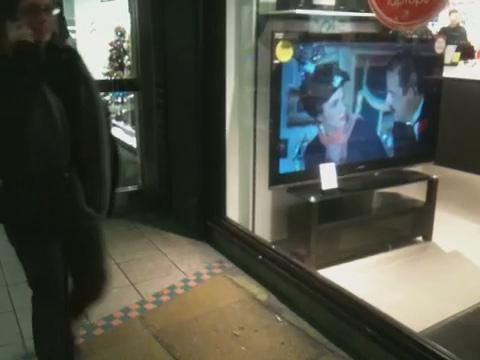Question: why is it blurry?
Choices:
A. Camera out of focus.
B. There is a smudge.
C. It is seen through a window.
D. The camera was shaky.
Answer with the letter. Answer: C Question: what is the person walking doing?
Choices:
A. Chewing gum.
B. Waving arms around.
C. Talking on a cell phone.
D. Skipping.
Answer with the letter. Answer: C Question: who is pictured on the television?
Choices:
A. A man and a woman.
B. Men.
C. Women.
D. Children.
Answer with the letter. Answer: A Question: when is this taken?
Choices:
A. Early morning.
B. Day time.
C. Night time.
D. Midnight.
Answer with the letter. Answer: C Question: what electronics are pictured?
Choices:
A. A tablet.
B. A television.
C. A phone.
D. A laptop.
Answer with the letter. Answer: B Question: what does the woman on the television have on her head?
Choices:
A. A cat.
B. A beret.
C. A hat.
D. A hair tie.
Answer with the letter. Answer: C 